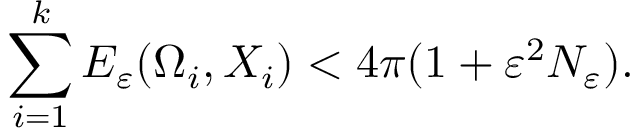<formula> <loc_0><loc_0><loc_500><loc_500>\sum _ { i = 1 } ^ { k } E _ { \varepsilon } ( \Omega _ { i } , X _ { i } ) < 4 \pi ( 1 + \varepsilon ^ { 2 } N _ { \varepsilon } ) .</formula> 